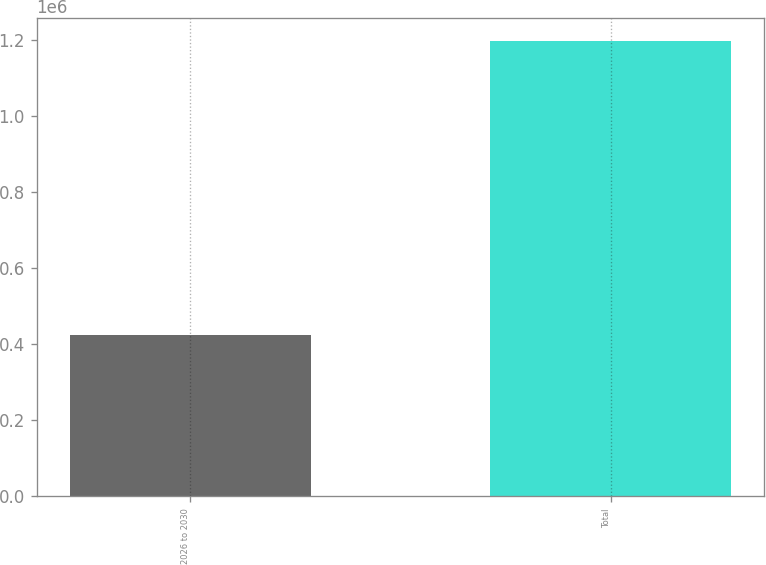Convert chart to OTSL. <chart><loc_0><loc_0><loc_500><loc_500><bar_chart><fcel>2026 to 2030<fcel>Total<nl><fcel>423398<fcel>1.19761e+06<nl></chart> 